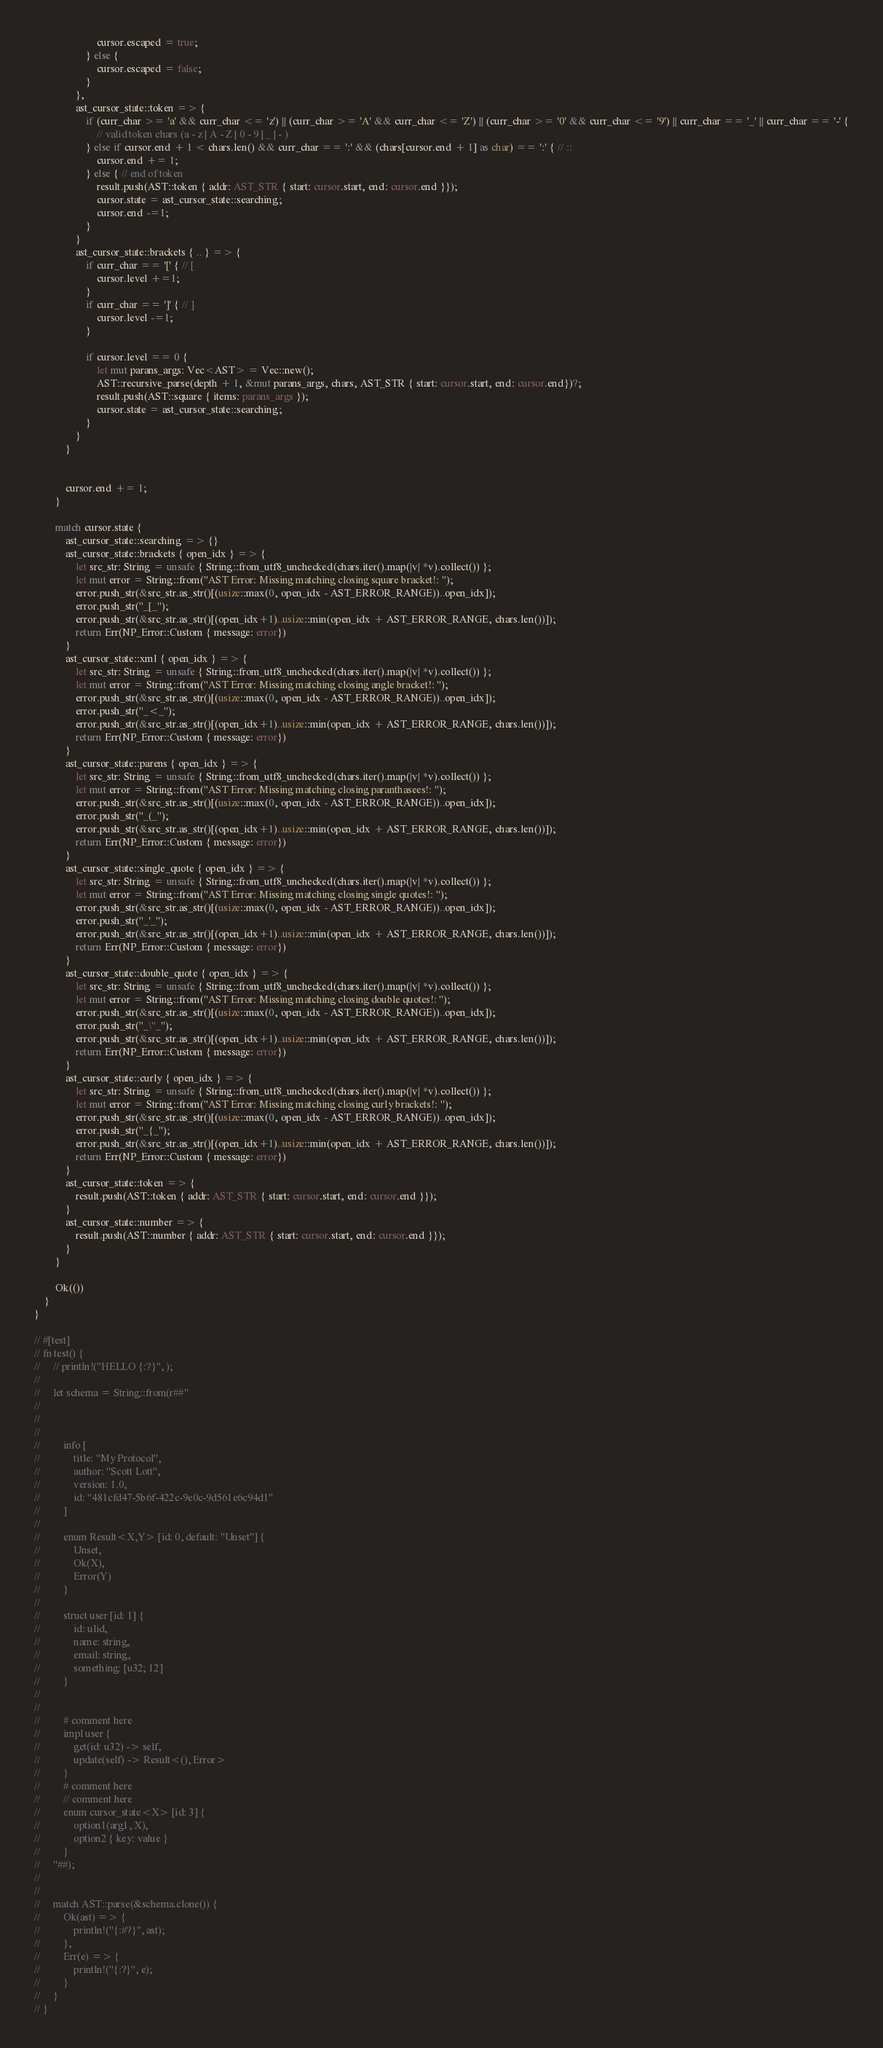Convert code to text. <code><loc_0><loc_0><loc_500><loc_500><_Rust_>                        cursor.escaped = true;
                    } else {
                        cursor.escaped = false;
                    }
                },
                ast_cursor_state::token => {
                    if (curr_char >= 'a' && curr_char <= 'z') || (curr_char >= 'A' && curr_char <= 'Z') || (curr_char >= '0' && curr_char <= '9') || curr_char == '_' || curr_char == '-' {
                        // valid token chars (a - z | A - Z | 0 - 9 | _ | - )
                    } else if cursor.end + 1 < chars.len() && curr_char == ':' && (chars[cursor.end + 1] as char) == ':' { // ::
                        cursor.end += 1;
                    } else { // end of token
                        result.push(AST::token { addr: AST_STR { start: cursor.start, end: cursor.end }});
                        cursor.state = ast_cursor_state::searching;
                        cursor.end -=1;
                    }
                }
                ast_cursor_state::brackets { .. } => {
                    if curr_char == '[' { // [
                        cursor.level +=1;
                    }
                    if curr_char == ']' { // ]
                        cursor.level -=1;
                    }

                    if cursor.level == 0 {
                        let mut parans_args: Vec<AST> = Vec::new();
                        AST::recursive_parse(depth + 1, &mut parans_args, chars, AST_STR { start: cursor.start, end: cursor.end})?;
                        result.push(AST::square { items: parans_args });
                        cursor.state = ast_cursor_state::searching;
                    }
                }
            }


            cursor.end += 1;
        }

        match cursor.state {
            ast_cursor_state::searching => {}
            ast_cursor_state::brackets { open_idx } => {
                let src_str: String = unsafe { String::from_utf8_unchecked(chars.iter().map(|v| *v).collect()) };
                let mut error = String::from("AST Error: Missing matching closing square bracket!: ");
                error.push_str(&src_str.as_str()[(usize::max(0, open_idx - AST_ERROR_RANGE))..open_idx]);
                error.push_str("_[_");
                error.push_str(&src_str.as_str()[(open_idx+1)..usize::min(open_idx + AST_ERROR_RANGE, chars.len())]);
                return Err(NP_Error::Custom { message: error})    
            }
            ast_cursor_state::xml { open_idx } => {
                let src_str: String = unsafe { String::from_utf8_unchecked(chars.iter().map(|v| *v).collect()) };
                let mut error = String::from("AST Error: Missing matching closing angle bracket!: ");
                error.push_str(&src_str.as_str()[(usize::max(0, open_idx - AST_ERROR_RANGE))..open_idx]);
                error.push_str("_<_");
                error.push_str(&src_str.as_str()[(open_idx+1)..usize::min(open_idx + AST_ERROR_RANGE, chars.len())]);
                return Err(NP_Error::Custom { message: error})
            }
            ast_cursor_state::parens { open_idx } => {
                let src_str: String = unsafe { String::from_utf8_unchecked(chars.iter().map(|v| *v).collect()) };
                let mut error = String::from("AST Error: Missing matching closing paranthasees!: ");
                error.push_str(&src_str.as_str()[(usize::max(0, open_idx - AST_ERROR_RANGE))..open_idx]);
                error.push_str("_(_");
                error.push_str(&src_str.as_str()[(open_idx+1)..usize::min(open_idx + AST_ERROR_RANGE, chars.len())]);
                return Err(NP_Error::Custom { message: error})
            }
            ast_cursor_state::single_quote { open_idx } => {
                let src_str: String = unsafe { String::from_utf8_unchecked(chars.iter().map(|v| *v).collect()) };
                let mut error = String::from("AST Error: Missing matching closing single quotes!: ");
                error.push_str(&src_str.as_str()[(usize::max(0, open_idx - AST_ERROR_RANGE))..open_idx]);
                error.push_str("_'_");
                error.push_str(&src_str.as_str()[(open_idx+1)..usize::min(open_idx + AST_ERROR_RANGE, chars.len())]);
                return Err(NP_Error::Custom { message: error})
            }
            ast_cursor_state::double_quote { open_idx } => {
                let src_str: String = unsafe { String::from_utf8_unchecked(chars.iter().map(|v| *v).collect()) };
                let mut error = String::from("AST Error: Missing matching closing double quotes!: ");
                error.push_str(&src_str.as_str()[(usize::max(0, open_idx - AST_ERROR_RANGE))..open_idx]);
                error.push_str("_\"_");
                error.push_str(&src_str.as_str()[(open_idx+1)..usize::min(open_idx + AST_ERROR_RANGE, chars.len())]);
                return Err(NP_Error::Custom { message: error})
            }
            ast_cursor_state::curly { open_idx } => {
                let src_str: String = unsafe { String::from_utf8_unchecked(chars.iter().map(|v| *v).collect()) };
                let mut error = String::from("AST Error: Missing matching closing curly brackets!: ");
                error.push_str(&src_str.as_str()[(usize::max(0, open_idx - AST_ERROR_RANGE))..open_idx]);
                error.push_str("_{_");
                error.push_str(&src_str.as_str()[(open_idx+1)..usize::min(open_idx + AST_ERROR_RANGE, chars.len())]);
                return Err(NP_Error::Custom { message: error})
            }
            ast_cursor_state::token => {
                result.push(AST::token { addr: AST_STR { start: cursor.start, end: cursor.end }});
            }
            ast_cursor_state::number => {
                result.push(AST::number { addr: AST_STR { start: cursor.start, end: cursor.end }});
            }
        }

        Ok(())
    }
}

// #[test]
// fn test() {
//     // println!("HELLO {:?}", );
//
//     let schema = String::from(r##"
//
//
//
//         info [
//             title: "My Protocol",
//             author: "Scott Lott",
//             version: 1.0,
//             id: "481cfd47-5b6f-422c-9e0c-9d561e6c94d1"
//         ]
//
//         enum Result<X,Y> [id: 0, default: "Unset"] {
//             Unset,
//             Ok(X),
//             Error(Y)
//         }
//
//         struct user [id: 1] {
//             id: ulid,
//             name: string,
//             email: string,
//             something: [u32; 12]
//         }
//
//
//         # comment here
//         impl user {
//             get(id: u32) -> self,
//             update(self) -> Result<(), Error>
//         }
//         # comment here
//         // comment here
//         enum cursor_state<X> [id: 3] {
//             option1(arg1, X),
//             option2 { key: value }
//         }
//     "##);
//
//
//     match AST::parse(&schema.clone()) {
//         Ok(ast) => {
//             println!("{:#?}", ast);
//         },
//         Err(e) => {
//             println!("{:?}", e);
//         }
//     }
// }</code> 